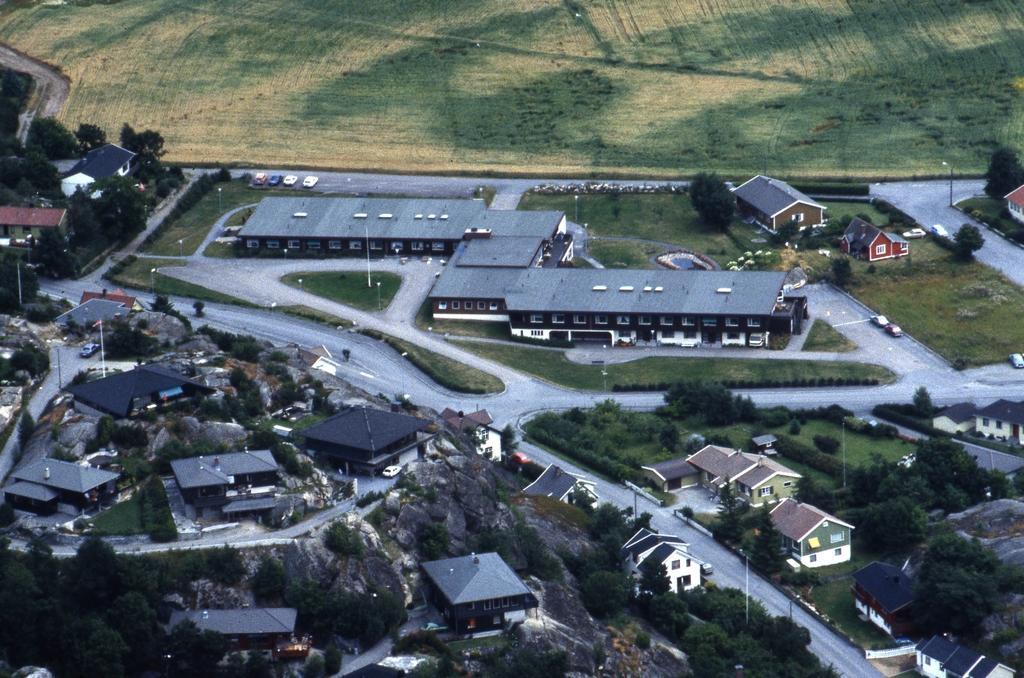Describe this image in one or two sentences. This is an aerial view image. In this image we can see ground, motor vehicles on the roads, street poles, street lights, trees, bushes, buildings and rocks. 